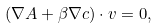<formula> <loc_0><loc_0><loc_500><loc_500>( \nabla A + \beta \nabla c ) \cdot { v } = 0 ,</formula> 